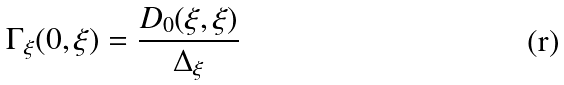Convert formula to latex. <formula><loc_0><loc_0><loc_500><loc_500>\Gamma _ { \xi } ( 0 , \xi ) = \frac { D _ { 0 } ( \xi , \xi ) } { \Delta _ { \xi } }</formula> 